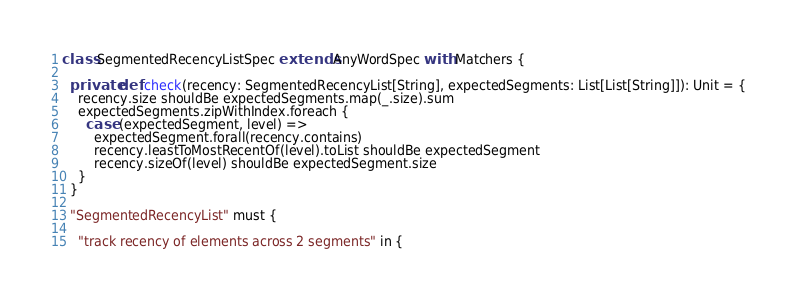<code> <loc_0><loc_0><loc_500><loc_500><_Scala_>
class SegmentedRecencyListSpec extends AnyWordSpec with Matchers {

  private def check(recency: SegmentedRecencyList[String], expectedSegments: List[List[String]]): Unit = {
    recency.size shouldBe expectedSegments.map(_.size).sum
    expectedSegments.zipWithIndex.foreach {
      case (expectedSegment, level) =>
        expectedSegment.forall(recency.contains)
        recency.leastToMostRecentOf(level).toList shouldBe expectedSegment
        recency.sizeOf(level) shouldBe expectedSegment.size
    }
  }

  "SegmentedRecencyList" must {

    "track recency of elements across 2 segments" in {</code> 